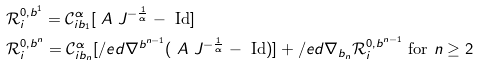Convert formula to latex. <formula><loc_0><loc_0><loc_500><loc_500>& \mathcal { R } ^ { 0 , b ^ { 1 } } _ { i } = \mathcal { C } _ { i b _ { 1 } } ^ { \alpha } [ \ A \ J ^ { - \frac { 1 } { \alpha } } - \text { Id} ] \\ & \mathcal { R } ^ { 0 , b ^ { n } } _ { i } = \mathcal { C } _ { i b _ { n } } ^ { \alpha } [ \slash e d \nabla ^ { b ^ { n - 1 } } ( \ A \ J ^ { - \frac { 1 } { \alpha } } - \text { Id} ) ] + \slash e d \nabla _ { b _ { n } } \mathcal { R } ^ { 0 , b ^ { n - 1 } } _ { i } \text { for } n \geq 2</formula> 